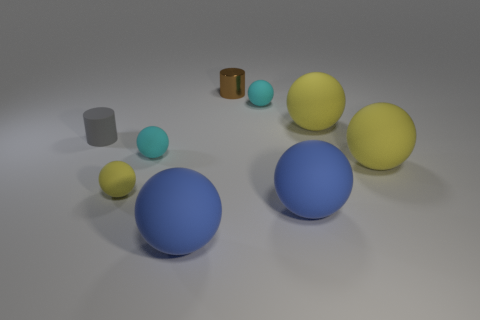What is the shape of the rubber thing on the left side of the yellow rubber object that is to the left of the tiny brown shiny cylinder? The rubber object to the left side of the yellow ball, which is in turn to the left of the small brown shiny cylinder, is cylindrical in shape, resembling a short column with circular ends. 